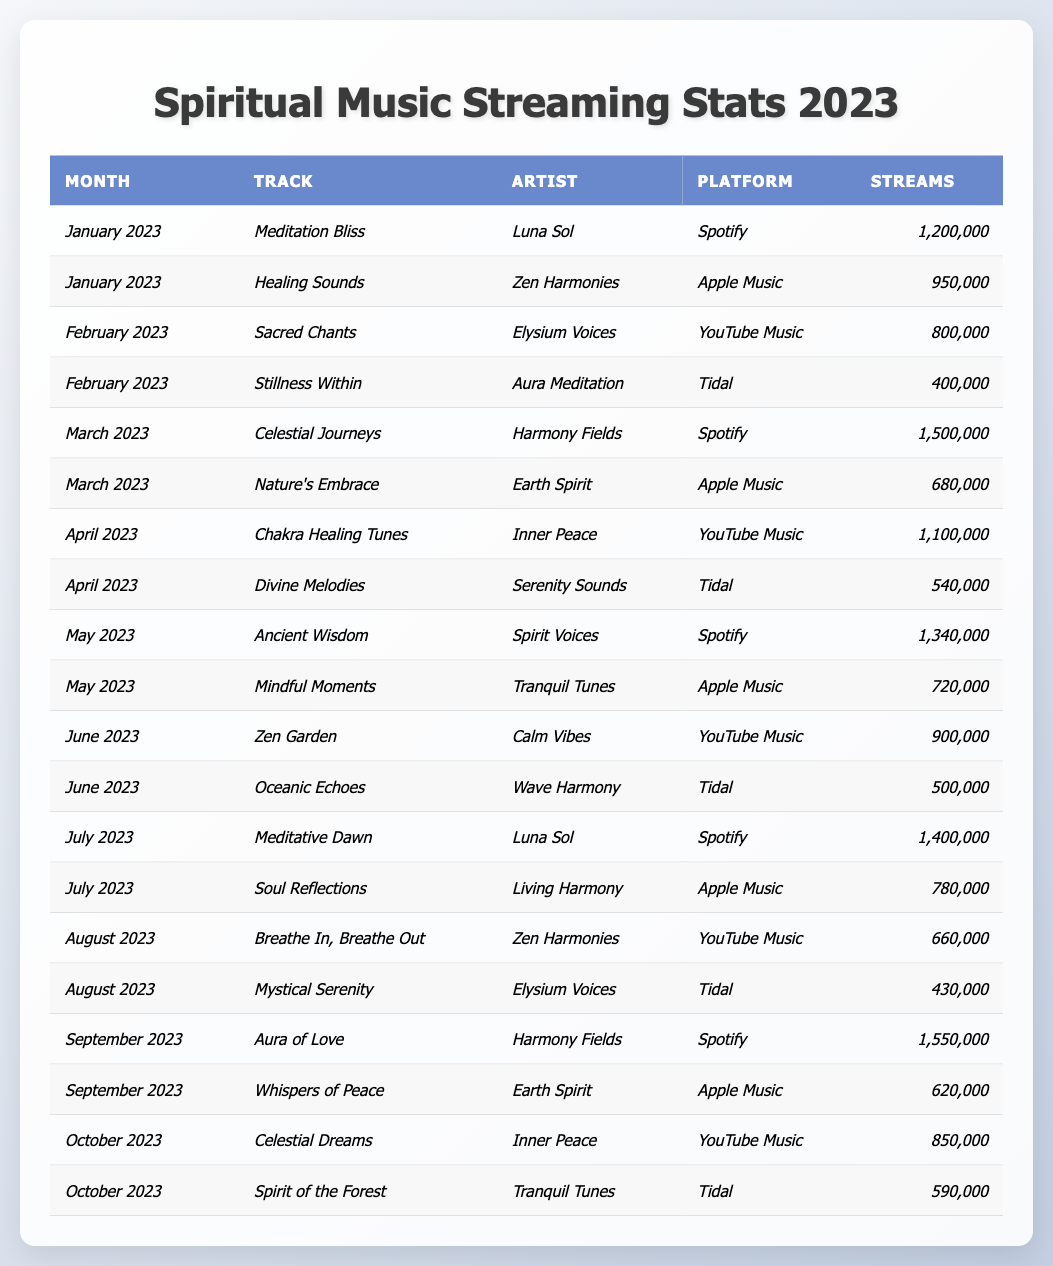What was the most streamed track in January 2023? In January 2023, the tracks listed are "Meditation Bliss" with 1,200,000 streams and "Healing Sounds" with 950,000 streams. The highest stream count is from "Meditation Bliss" at 1,200,000.
Answer: Meditation Bliss How many streams did "Sacred Chants" receive in February 2023? The track "Sacred Chants" by Elysium Voices received 800,000 streams in February 2023.
Answer: 800,000 Which artist had the highest streaming track in September 2023? In September 2023, the track "Aura of Love" by Harmony Fields had the highest streams with 1,550,000.
Answer: Harmony Fields What is the total number of streams for "Meditation Bliss" across all months? "Meditation Bliss" was streamed 1,200,000 times in January and 1,400,000 times in July, totaling 1,200,000 + 1,400,000 = 2,600,000.
Answer: 2,600,000 What percentage of total streams in March is from "Celestial Journeys"? In March, the total streams are 1,500,000 (Celestial Journeys) + 680,000 (Nature's Embrace) = 2,180,000. The percentage from "Celestial Journeys" is (1,500,000 / 2,180,000) × 100 = 68.9%.
Answer: 68.9% Is "Divine Melodies" more streamed than "Oceanic Echoes" in June 2023? In June, "Zen Garden" (900,000) is more streamed than "Oceanic Echoes" (500,000), and "Divine Melodies" was not streamed in June, so the comparison does not apply.
Answer: No Which month had the lowest total streams for all tracks listed? Total streams by month: January = 2,150,000, February = 1,200,000, March = 2,180,000, April = 1,640,000, May = 2,060,000, June = 1,400,000, July = 2,180,000, August = 1,090,000, September = 2,170,000, October = 1,440,000. The lowest is in June, with 1,400,000 streams.
Answer: June What is the difference in streams between the highest and lowest streamed track in August 2023? In August 2023, "Breathe In, Breathe Out" had 660,000 streams and "Mystical Serenity" had 430,000 streams. The difference is 660,000 - 430,000 = 230,000.
Answer: 230,000 How many platforms had tracks that reached 1 million streams or more overall? The tracks that reached 1 million or more are "Meditation Bliss," "Celestial Journeys," "Chakra Healing Tunes," "Ancient Wisdom," "Meditative Dawn," and "Aura of Love," totaling 6 tracks. They are distributed across 4 platforms (Spotify, Apple Music, YouTube Music, Tidal).
Answer: 4 In which month did "Soul Reflections" have its streaming performance? "Soul Reflections" by Living Harmony had its streaming performance in July 2023 with 780,000 streams.
Answer: July 2023 